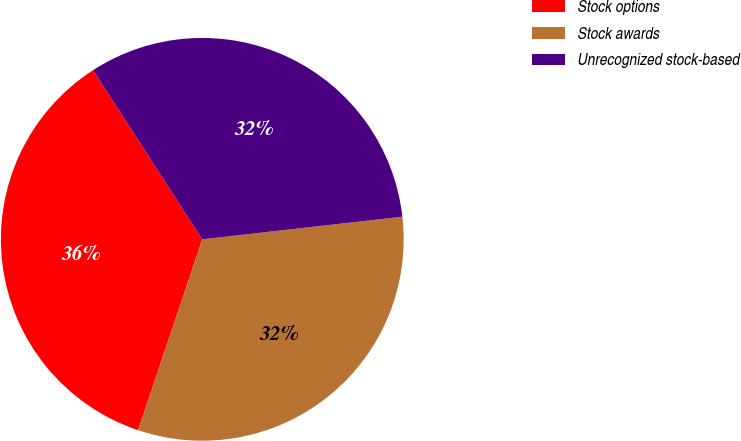Convert chart to OTSL. <chart><loc_0><loc_0><loc_500><loc_500><pie_chart><fcel>Stock options<fcel>Stock awards<fcel>Unrecognized stock-based<nl><fcel>35.71%<fcel>31.95%<fcel>32.33%<nl></chart> 